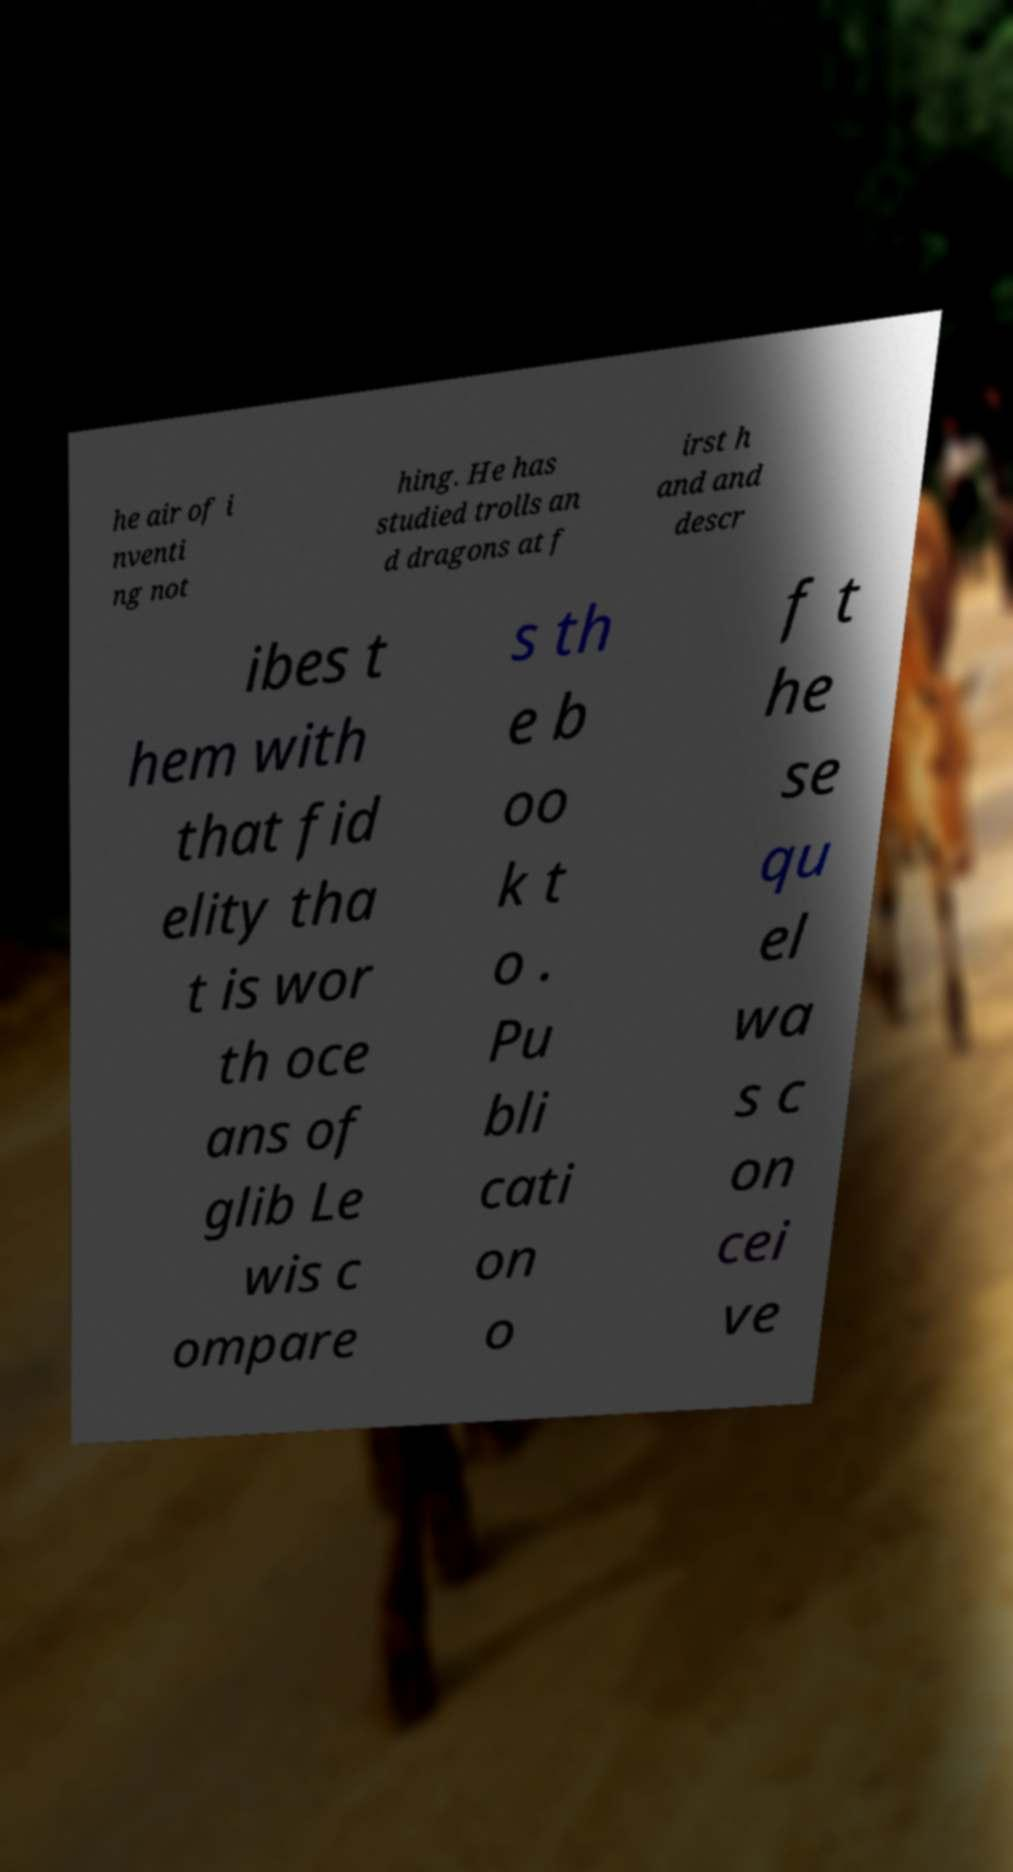Can you read and provide the text displayed in the image?This photo seems to have some interesting text. Can you extract and type it out for me? he air of i nventi ng not hing. He has studied trolls an d dragons at f irst h and and descr ibes t hem with that fid elity tha t is wor th oce ans of glib Le wis c ompare s th e b oo k t o . Pu bli cati on o f t he se qu el wa s c on cei ve 